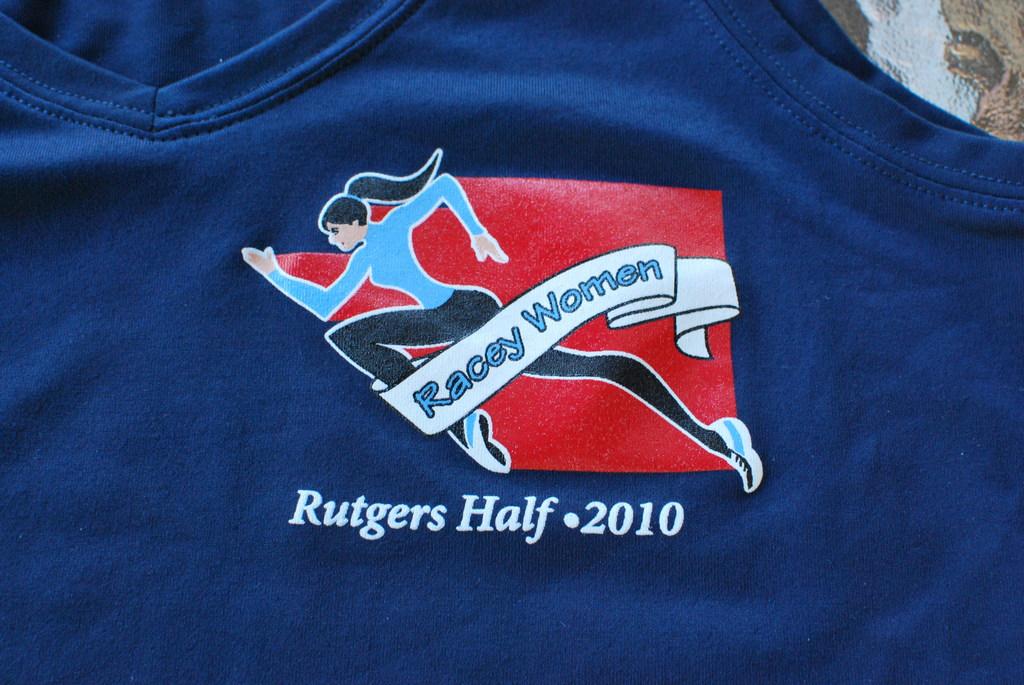What year was the race the t-shirt was worn for?
Ensure brevity in your answer.  2010. What half is mentioned on the shirt?
Your response must be concise. Rutgers. 